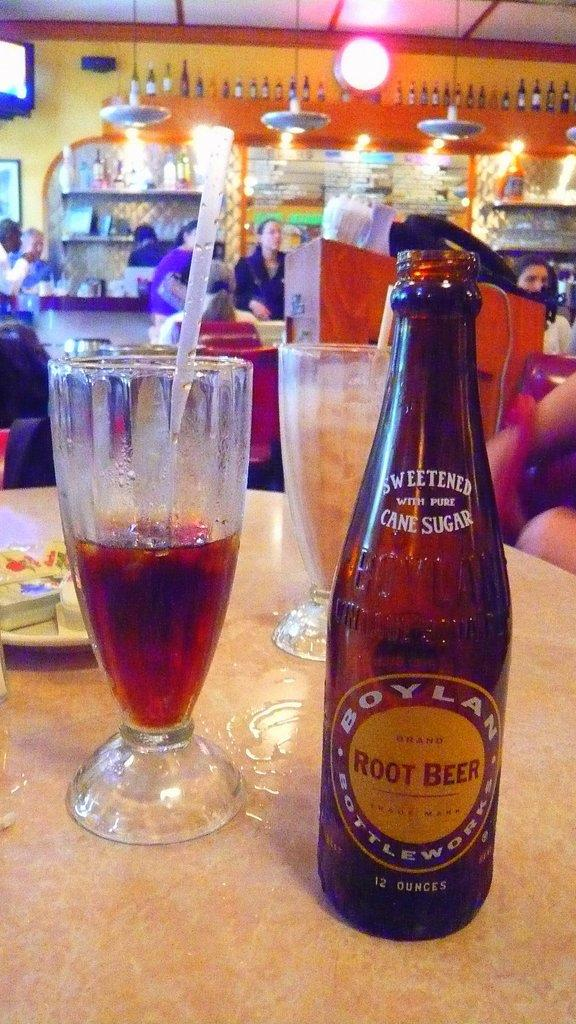<image>
Present a compact description of the photo's key features. Bottle of Boylan Root Beer next to glass nearly halfway full of it with ice and a straw on diner table. 